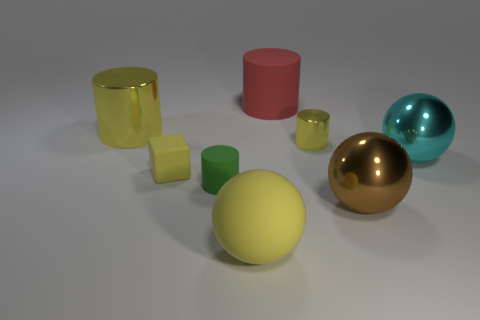There is a large cylinder that is the same color as the small cube; what is it made of?
Ensure brevity in your answer.  Metal. There is a tiny thing that is behind the big cyan ball; is it the same color as the rubber cube?
Offer a terse response. Yes. What number of other things are the same color as the matte cube?
Your answer should be very brief. 3. How many objects are either small yellow rubber objects or tiny brown matte spheres?
Your response must be concise. 1. Is the shape of the large matte thing that is behind the rubber sphere the same as  the tiny shiny object?
Provide a succinct answer. Yes. There is a small cylinder to the right of the big matte thing that is behind the rubber ball; what color is it?
Keep it short and to the point. Yellow. Is the number of blue cubes less than the number of yellow cubes?
Give a very brief answer. Yes. Are there any brown balls made of the same material as the green cylinder?
Offer a very short reply. No. There is a large cyan object; is its shape the same as the tiny yellow thing that is to the right of the rubber block?
Your response must be concise. No. There is a big brown metal sphere; are there any brown objects on the right side of it?
Your response must be concise. No. 